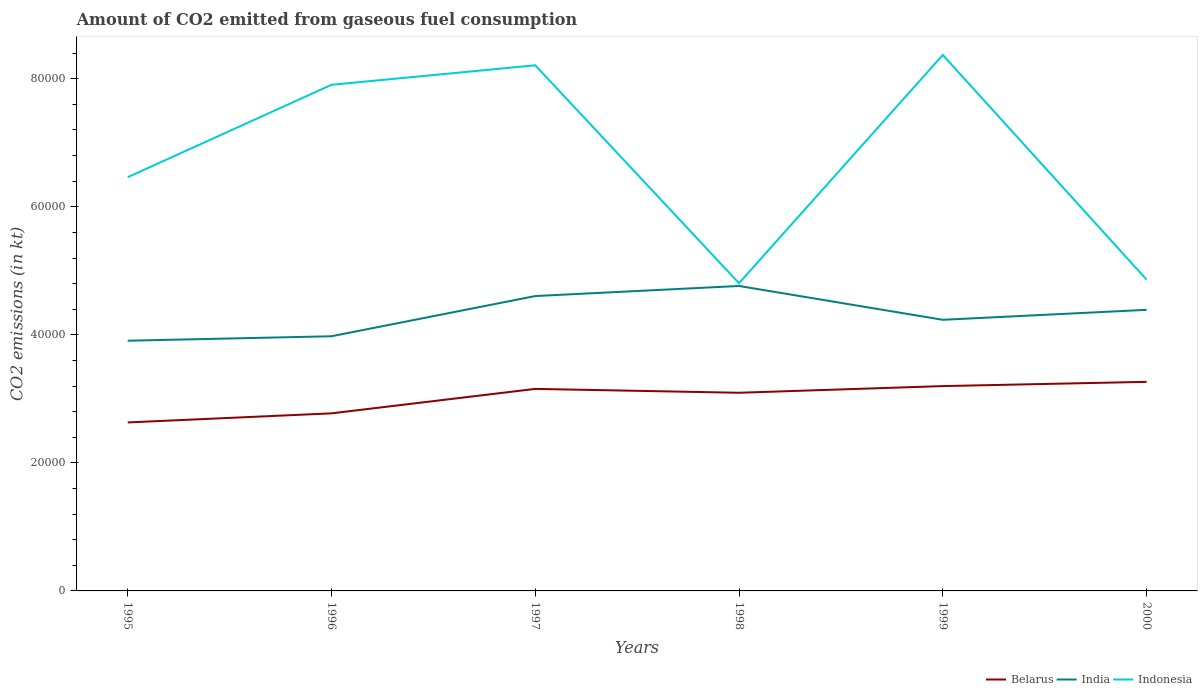Does the line corresponding to Indonesia intersect with the line corresponding to Belarus?
Make the answer very short. No. Across all years, what is the maximum amount of CO2 emitted in Indonesia?
Offer a terse response. 4.81e+04. What is the total amount of CO2 emitted in Indonesia in the graph?
Your answer should be compact. 3.51e+04. What is the difference between the highest and the second highest amount of CO2 emitted in Indonesia?
Your answer should be compact. 3.57e+04. What is the difference between the highest and the lowest amount of CO2 emitted in Indonesia?
Make the answer very short. 3. Is the amount of CO2 emitted in Belarus strictly greater than the amount of CO2 emitted in Indonesia over the years?
Provide a short and direct response. Yes. What is the difference between two consecutive major ticks on the Y-axis?
Ensure brevity in your answer.  2.00e+04. Does the graph contain grids?
Make the answer very short. No. How many legend labels are there?
Offer a very short reply. 3. What is the title of the graph?
Make the answer very short. Amount of CO2 emitted from gaseous fuel consumption. Does "Egypt, Arab Rep." appear as one of the legend labels in the graph?
Provide a short and direct response. No. What is the label or title of the Y-axis?
Keep it short and to the point. CO2 emissions (in kt). What is the CO2 emissions (in kt) in Belarus in 1995?
Offer a very short reply. 2.63e+04. What is the CO2 emissions (in kt) in India in 1995?
Offer a terse response. 3.91e+04. What is the CO2 emissions (in kt) in Indonesia in 1995?
Your answer should be very brief. 6.46e+04. What is the CO2 emissions (in kt) of Belarus in 1996?
Give a very brief answer. 2.77e+04. What is the CO2 emissions (in kt) in India in 1996?
Keep it short and to the point. 3.98e+04. What is the CO2 emissions (in kt) in Indonesia in 1996?
Provide a short and direct response. 7.91e+04. What is the CO2 emissions (in kt) of Belarus in 1997?
Offer a very short reply. 3.16e+04. What is the CO2 emissions (in kt) of India in 1997?
Offer a terse response. 4.61e+04. What is the CO2 emissions (in kt) of Indonesia in 1997?
Your answer should be compact. 8.21e+04. What is the CO2 emissions (in kt) of Belarus in 1998?
Your answer should be very brief. 3.10e+04. What is the CO2 emissions (in kt) in India in 1998?
Your answer should be compact. 4.76e+04. What is the CO2 emissions (in kt) in Indonesia in 1998?
Your answer should be compact. 4.81e+04. What is the CO2 emissions (in kt) in Belarus in 1999?
Ensure brevity in your answer.  3.20e+04. What is the CO2 emissions (in kt) in India in 1999?
Give a very brief answer. 4.24e+04. What is the CO2 emissions (in kt) of Indonesia in 1999?
Ensure brevity in your answer.  8.37e+04. What is the CO2 emissions (in kt) in Belarus in 2000?
Give a very brief answer. 3.27e+04. What is the CO2 emissions (in kt) of India in 2000?
Ensure brevity in your answer.  4.39e+04. What is the CO2 emissions (in kt) of Indonesia in 2000?
Provide a short and direct response. 4.86e+04. Across all years, what is the maximum CO2 emissions (in kt) of Belarus?
Your response must be concise. 3.27e+04. Across all years, what is the maximum CO2 emissions (in kt) of India?
Make the answer very short. 4.76e+04. Across all years, what is the maximum CO2 emissions (in kt) of Indonesia?
Provide a succinct answer. 8.37e+04. Across all years, what is the minimum CO2 emissions (in kt) in Belarus?
Keep it short and to the point. 2.63e+04. Across all years, what is the minimum CO2 emissions (in kt) of India?
Your answer should be very brief. 3.91e+04. Across all years, what is the minimum CO2 emissions (in kt) in Indonesia?
Your answer should be compact. 4.81e+04. What is the total CO2 emissions (in kt) in Belarus in the graph?
Give a very brief answer. 1.81e+05. What is the total CO2 emissions (in kt) in India in the graph?
Ensure brevity in your answer.  2.59e+05. What is the total CO2 emissions (in kt) in Indonesia in the graph?
Offer a terse response. 4.06e+05. What is the difference between the CO2 emissions (in kt) of Belarus in 1995 and that in 1996?
Ensure brevity in your answer.  -1419.13. What is the difference between the CO2 emissions (in kt) of India in 1995 and that in 1996?
Give a very brief answer. -696.73. What is the difference between the CO2 emissions (in kt) in Indonesia in 1995 and that in 1996?
Offer a very short reply. -1.44e+04. What is the difference between the CO2 emissions (in kt) of Belarus in 1995 and that in 1997?
Your answer should be compact. -5240.14. What is the difference between the CO2 emissions (in kt) of India in 1995 and that in 1997?
Provide a succinct answer. -6978.3. What is the difference between the CO2 emissions (in kt) in Indonesia in 1995 and that in 1997?
Your response must be concise. -1.75e+04. What is the difference between the CO2 emissions (in kt) in Belarus in 1995 and that in 1998?
Provide a succinct answer. -4635.09. What is the difference between the CO2 emissions (in kt) in India in 1995 and that in 1998?
Provide a short and direct response. -8551.44. What is the difference between the CO2 emissions (in kt) in Indonesia in 1995 and that in 1998?
Offer a terse response. 1.66e+04. What is the difference between the CO2 emissions (in kt) in Belarus in 1995 and that in 1999?
Make the answer very short. -5676.52. What is the difference between the CO2 emissions (in kt) in India in 1995 and that in 1999?
Offer a very short reply. -3267.3. What is the difference between the CO2 emissions (in kt) in Indonesia in 1995 and that in 1999?
Provide a short and direct response. -1.91e+04. What is the difference between the CO2 emissions (in kt) in Belarus in 1995 and that in 2000?
Offer a very short reply. -6340.24. What is the difference between the CO2 emissions (in kt) in India in 1995 and that in 2000?
Your response must be concise. -4825.77. What is the difference between the CO2 emissions (in kt) of Indonesia in 1995 and that in 2000?
Keep it short and to the point. 1.60e+04. What is the difference between the CO2 emissions (in kt) in Belarus in 1996 and that in 1997?
Make the answer very short. -3821.01. What is the difference between the CO2 emissions (in kt) of India in 1996 and that in 1997?
Your response must be concise. -6281.57. What is the difference between the CO2 emissions (in kt) of Indonesia in 1996 and that in 1997?
Give a very brief answer. -3050.94. What is the difference between the CO2 emissions (in kt) of Belarus in 1996 and that in 1998?
Give a very brief answer. -3215.96. What is the difference between the CO2 emissions (in kt) in India in 1996 and that in 1998?
Keep it short and to the point. -7854.71. What is the difference between the CO2 emissions (in kt) in Indonesia in 1996 and that in 1998?
Offer a terse response. 3.10e+04. What is the difference between the CO2 emissions (in kt) of Belarus in 1996 and that in 1999?
Offer a terse response. -4257.39. What is the difference between the CO2 emissions (in kt) of India in 1996 and that in 1999?
Your response must be concise. -2570.57. What is the difference between the CO2 emissions (in kt) in Indonesia in 1996 and that in 1999?
Make the answer very short. -4664.42. What is the difference between the CO2 emissions (in kt) in Belarus in 1996 and that in 2000?
Offer a very short reply. -4921.11. What is the difference between the CO2 emissions (in kt) in India in 1996 and that in 2000?
Provide a short and direct response. -4129.04. What is the difference between the CO2 emissions (in kt) in Indonesia in 1996 and that in 2000?
Offer a terse response. 3.04e+04. What is the difference between the CO2 emissions (in kt) in Belarus in 1997 and that in 1998?
Your answer should be very brief. 605.05. What is the difference between the CO2 emissions (in kt) in India in 1997 and that in 1998?
Ensure brevity in your answer.  -1573.14. What is the difference between the CO2 emissions (in kt) of Indonesia in 1997 and that in 1998?
Offer a very short reply. 3.40e+04. What is the difference between the CO2 emissions (in kt) in Belarus in 1997 and that in 1999?
Ensure brevity in your answer.  -436.37. What is the difference between the CO2 emissions (in kt) of India in 1997 and that in 1999?
Offer a very short reply. 3711. What is the difference between the CO2 emissions (in kt) of Indonesia in 1997 and that in 1999?
Ensure brevity in your answer.  -1613.48. What is the difference between the CO2 emissions (in kt) in Belarus in 1997 and that in 2000?
Ensure brevity in your answer.  -1100.1. What is the difference between the CO2 emissions (in kt) of India in 1997 and that in 2000?
Your answer should be very brief. 2152.53. What is the difference between the CO2 emissions (in kt) of Indonesia in 1997 and that in 2000?
Give a very brief answer. 3.35e+04. What is the difference between the CO2 emissions (in kt) in Belarus in 1998 and that in 1999?
Keep it short and to the point. -1041.43. What is the difference between the CO2 emissions (in kt) in India in 1998 and that in 1999?
Offer a terse response. 5284.15. What is the difference between the CO2 emissions (in kt) in Indonesia in 1998 and that in 1999?
Ensure brevity in your answer.  -3.57e+04. What is the difference between the CO2 emissions (in kt) in Belarus in 1998 and that in 2000?
Your answer should be compact. -1705.15. What is the difference between the CO2 emissions (in kt) in India in 1998 and that in 2000?
Ensure brevity in your answer.  3725.67. What is the difference between the CO2 emissions (in kt) in Indonesia in 1998 and that in 2000?
Ensure brevity in your answer.  -564.72. What is the difference between the CO2 emissions (in kt) in Belarus in 1999 and that in 2000?
Ensure brevity in your answer.  -663.73. What is the difference between the CO2 emissions (in kt) of India in 1999 and that in 2000?
Ensure brevity in your answer.  -1558.47. What is the difference between the CO2 emissions (in kt) of Indonesia in 1999 and that in 2000?
Offer a very short reply. 3.51e+04. What is the difference between the CO2 emissions (in kt) in Belarus in 1995 and the CO2 emissions (in kt) in India in 1996?
Provide a succinct answer. -1.35e+04. What is the difference between the CO2 emissions (in kt) in Belarus in 1995 and the CO2 emissions (in kt) in Indonesia in 1996?
Provide a succinct answer. -5.27e+04. What is the difference between the CO2 emissions (in kt) of India in 1995 and the CO2 emissions (in kt) of Indonesia in 1996?
Offer a terse response. -4.00e+04. What is the difference between the CO2 emissions (in kt) of Belarus in 1995 and the CO2 emissions (in kt) of India in 1997?
Your response must be concise. -1.97e+04. What is the difference between the CO2 emissions (in kt) of Belarus in 1995 and the CO2 emissions (in kt) of Indonesia in 1997?
Your answer should be very brief. -5.58e+04. What is the difference between the CO2 emissions (in kt) of India in 1995 and the CO2 emissions (in kt) of Indonesia in 1997?
Provide a succinct answer. -4.30e+04. What is the difference between the CO2 emissions (in kt) in Belarus in 1995 and the CO2 emissions (in kt) in India in 1998?
Keep it short and to the point. -2.13e+04. What is the difference between the CO2 emissions (in kt) in Belarus in 1995 and the CO2 emissions (in kt) in Indonesia in 1998?
Make the answer very short. -2.17e+04. What is the difference between the CO2 emissions (in kt) in India in 1995 and the CO2 emissions (in kt) in Indonesia in 1998?
Your answer should be compact. -8984.15. What is the difference between the CO2 emissions (in kt) of Belarus in 1995 and the CO2 emissions (in kt) of India in 1999?
Give a very brief answer. -1.60e+04. What is the difference between the CO2 emissions (in kt) of Belarus in 1995 and the CO2 emissions (in kt) of Indonesia in 1999?
Ensure brevity in your answer.  -5.74e+04. What is the difference between the CO2 emissions (in kt) in India in 1995 and the CO2 emissions (in kt) in Indonesia in 1999?
Make the answer very short. -4.46e+04. What is the difference between the CO2 emissions (in kt) in Belarus in 1995 and the CO2 emissions (in kt) in India in 2000?
Provide a succinct answer. -1.76e+04. What is the difference between the CO2 emissions (in kt) in Belarus in 1995 and the CO2 emissions (in kt) in Indonesia in 2000?
Your answer should be very brief. -2.23e+04. What is the difference between the CO2 emissions (in kt) of India in 1995 and the CO2 emissions (in kt) of Indonesia in 2000?
Your answer should be compact. -9548.87. What is the difference between the CO2 emissions (in kt) of Belarus in 1996 and the CO2 emissions (in kt) of India in 1997?
Offer a terse response. -1.83e+04. What is the difference between the CO2 emissions (in kt) in Belarus in 1996 and the CO2 emissions (in kt) in Indonesia in 1997?
Give a very brief answer. -5.44e+04. What is the difference between the CO2 emissions (in kt) of India in 1996 and the CO2 emissions (in kt) of Indonesia in 1997?
Provide a succinct answer. -4.23e+04. What is the difference between the CO2 emissions (in kt) of Belarus in 1996 and the CO2 emissions (in kt) of India in 1998?
Your answer should be compact. -1.99e+04. What is the difference between the CO2 emissions (in kt) of Belarus in 1996 and the CO2 emissions (in kt) of Indonesia in 1998?
Make the answer very short. -2.03e+04. What is the difference between the CO2 emissions (in kt) of India in 1996 and the CO2 emissions (in kt) of Indonesia in 1998?
Offer a very short reply. -8287.42. What is the difference between the CO2 emissions (in kt) in Belarus in 1996 and the CO2 emissions (in kt) in India in 1999?
Keep it short and to the point. -1.46e+04. What is the difference between the CO2 emissions (in kt) of Belarus in 1996 and the CO2 emissions (in kt) of Indonesia in 1999?
Your response must be concise. -5.60e+04. What is the difference between the CO2 emissions (in kt) in India in 1996 and the CO2 emissions (in kt) in Indonesia in 1999?
Ensure brevity in your answer.  -4.39e+04. What is the difference between the CO2 emissions (in kt) in Belarus in 1996 and the CO2 emissions (in kt) in India in 2000?
Offer a very short reply. -1.62e+04. What is the difference between the CO2 emissions (in kt) of Belarus in 1996 and the CO2 emissions (in kt) of Indonesia in 2000?
Provide a short and direct response. -2.09e+04. What is the difference between the CO2 emissions (in kt) in India in 1996 and the CO2 emissions (in kt) in Indonesia in 2000?
Offer a terse response. -8852.14. What is the difference between the CO2 emissions (in kt) in Belarus in 1997 and the CO2 emissions (in kt) in India in 1998?
Provide a short and direct response. -1.61e+04. What is the difference between the CO2 emissions (in kt) in Belarus in 1997 and the CO2 emissions (in kt) in Indonesia in 1998?
Your response must be concise. -1.65e+04. What is the difference between the CO2 emissions (in kt) in India in 1997 and the CO2 emissions (in kt) in Indonesia in 1998?
Keep it short and to the point. -2005.85. What is the difference between the CO2 emissions (in kt) in Belarus in 1997 and the CO2 emissions (in kt) in India in 1999?
Your response must be concise. -1.08e+04. What is the difference between the CO2 emissions (in kt) of Belarus in 1997 and the CO2 emissions (in kt) of Indonesia in 1999?
Ensure brevity in your answer.  -5.22e+04. What is the difference between the CO2 emissions (in kt) of India in 1997 and the CO2 emissions (in kt) of Indonesia in 1999?
Your response must be concise. -3.77e+04. What is the difference between the CO2 emissions (in kt) in Belarus in 1997 and the CO2 emissions (in kt) in India in 2000?
Offer a terse response. -1.24e+04. What is the difference between the CO2 emissions (in kt) in Belarus in 1997 and the CO2 emissions (in kt) in Indonesia in 2000?
Give a very brief answer. -1.71e+04. What is the difference between the CO2 emissions (in kt) of India in 1997 and the CO2 emissions (in kt) of Indonesia in 2000?
Provide a short and direct response. -2570.57. What is the difference between the CO2 emissions (in kt) of Belarus in 1998 and the CO2 emissions (in kt) of India in 1999?
Your response must be concise. -1.14e+04. What is the difference between the CO2 emissions (in kt) of Belarus in 1998 and the CO2 emissions (in kt) of Indonesia in 1999?
Keep it short and to the point. -5.28e+04. What is the difference between the CO2 emissions (in kt) in India in 1998 and the CO2 emissions (in kt) in Indonesia in 1999?
Offer a terse response. -3.61e+04. What is the difference between the CO2 emissions (in kt) in Belarus in 1998 and the CO2 emissions (in kt) in India in 2000?
Offer a terse response. -1.30e+04. What is the difference between the CO2 emissions (in kt) in Belarus in 1998 and the CO2 emissions (in kt) in Indonesia in 2000?
Provide a short and direct response. -1.77e+04. What is the difference between the CO2 emissions (in kt) of India in 1998 and the CO2 emissions (in kt) of Indonesia in 2000?
Provide a short and direct response. -997.42. What is the difference between the CO2 emissions (in kt) of Belarus in 1999 and the CO2 emissions (in kt) of India in 2000?
Offer a terse response. -1.19e+04. What is the difference between the CO2 emissions (in kt) in Belarus in 1999 and the CO2 emissions (in kt) in Indonesia in 2000?
Ensure brevity in your answer.  -1.66e+04. What is the difference between the CO2 emissions (in kt) in India in 1999 and the CO2 emissions (in kt) in Indonesia in 2000?
Offer a very short reply. -6281.57. What is the average CO2 emissions (in kt) in Belarus per year?
Your answer should be very brief. 3.02e+04. What is the average CO2 emissions (in kt) of India per year?
Ensure brevity in your answer.  4.31e+04. What is the average CO2 emissions (in kt) in Indonesia per year?
Your response must be concise. 6.77e+04. In the year 1995, what is the difference between the CO2 emissions (in kt) in Belarus and CO2 emissions (in kt) in India?
Offer a very short reply. -1.28e+04. In the year 1995, what is the difference between the CO2 emissions (in kt) in Belarus and CO2 emissions (in kt) in Indonesia?
Keep it short and to the point. -3.83e+04. In the year 1995, what is the difference between the CO2 emissions (in kt) in India and CO2 emissions (in kt) in Indonesia?
Keep it short and to the point. -2.55e+04. In the year 1996, what is the difference between the CO2 emissions (in kt) in Belarus and CO2 emissions (in kt) in India?
Offer a terse response. -1.20e+04. In the year 1996, what is the difference between the CO2 emissions (in kt) in Belarus and CO2 emissions (in kt) in Indonesia?
Ensure brevity in your answer.  -5.13e+04. In the year 1996, what is the difference between the CO2 emissions (in kt) of India and CO2 emissions (in kt) of Indonesia?
Ensure brevity in your answer.  -3.93e+04. In the year 1997, what is the difference between the CO2 emissions (in kt) in Belarus and CO2 emissions (in kt) in India?
Offer a very short reply. -1.45e+04. In the year 1997, what is the difference between the CO2 emissions (in kt) of Belarus and CO2 emissions (in kt) of Indonesia?
Provide a succinct answer. -5.05e+04. In the year 1997, what is the difference between the CO2 emissions (in kt) of India and CO2 emissions (in kt) of Indonesia?
Offer a very short reply. -3.60e+04. In the year 1998, what is the difference between the CO2 emissions (in kt) in Belarus and CO2 emissions (in kt) in India?
Offer a terse response. -1.67e+04. In the year 1998, what is the difference between the CO2 emissions (in kt) in Belarus and CO2 emissions (in kt) in Indonesia?
Provide a short and direct response. -1.71e+04. In the year 1998, what is the difference between the CO2 emissions (in kt) of India and CO2 emissions (in kt) of Indonesia?
Give a very brief answer. -432.71. In the year 1999, what is the difference between the CO2 emissions (in kt) in Belarus and CO2 emissions (in kt) in India?
Your answer should be very brief. -1.04e+04. In the year 1999, what is the difference between the CO2 emissions (in kt) in Belarus and CO2 emissions (in kt) in Indonesia?
Your answer should be compact. -5.17e+04. In the year 1999, what is the difference between the CO2 emissions (in kt) of India and CO2 emissions (in kt) of Indonesia?
Offer a very short reply. -4.14e+04. In the year 2000, what is the difference between the CO2 emissions (in kt) of Belarus and CO2 emissions (in kt) of India?
Your response must be concise. -1.13e+04. In the year 2000, what is the difference between the CO2 emissions (in kt) of Belarus and CO2 emissions (in kt) of Indonesia?
Offer a terse response. -1.60e+04. In the year 2000, what is the difference between the CO2 emissions (in kt) of India and CO2 emissions (in kt) of Indonesia?
Your response must be concise. -4723.1. What is the ratio of the CO2 emissions (in kt) in Belarus in 1995 to that in 1996?
Ensure brevity in your answer.  0.95. What is the ratio of the CO2 emissions (in kt) of India in 1995 to that in 1996?
Provide a succinct answer. 0.98. What is the ratio of the CO2 emissions (in kt) in Indonesia in 1995 to that in 1996?
Provide a short and direct response. 0.82. What is the ratio of the CO2 emissions (in kt) in Belarus in 1995 to that in 1997?
Ensure brevity in your answer.  0.83. What is the ratio of the CO2 emissions (in kt) in India in 1995 to that in 1997?
Give a very brief answer. 0.85. What is the ratio of the CO2 emissions (in kt) of Indonesia in 1995 to that in 1997?
Your answer should be compact. 0.79. What is the ratio of the CO2 emissions (in kt) in Belarus in 1995 to that in 1998?
Provide a short and direct response. 0.85. What is the ratio of the CO2 emissions (in kt) in India in 1995 to that in 1998?
Offer a very short reply. 0.82. What is the ratio of the CO2 emissions (in kt) of Indonesia in 1995 to that in 1998?
Offer a very short reply. 1.34. What is the ratio of the CO2 emissions (in kt) of Belarus in 1995 to that in 1999?
Your answer should be compact. 0.82. What is the ratio of the CO2 emissions (in kt) in India in 1995 to that in 1999?
Give a very brief answer. 0.92. What is the ratio of the CO2 emissions (in kt) of Indonesia in 1995 to that in 1999?
Provide a succinct answer. 0.77. What is the ratio of the CO2 emissions (in kt) in Belarus in 1995 to that in 2000?
Provide a succinct answer. 0.81. What is the ratio of the CO2 emissions (in kt) in India in 1995 to that in 2000?
Offer a terse response. 0.89. What is the ratio of the CO2 emissions (in kt) in Indonesia in 1995 to that in 2000?
Provide a succinct answer. 1.33. What is the ratio of the CO2 emissions (in kt) of Belarus in 1996 to that in 1997?
Keep it short and to the point. 0.88. What is the ratio of the CO2 emissions (in kt) in India in 1996 to that in 1997?
Your answer should be compact. 0.86. What is the ratio of the CO2 emissions (in kt) of Indonesia in 1996 to that in 1997?
Ensure brevity in your answer.  0.96. What is the ratio of the CO2 emissions (in kt) in Belarus in 1996 to that in 1998?
Your answer should be very brief. 0.9. What is the ratio of the CO2 emissions (in kt) of India in 1996 to that in 1998?
Make the answer very short. 0.84. What is the ratio of the CO2 emissions (in kt) of Indonesia in 1996 to that in 1998?
Keep it short and to the point. 1.64. What is the ratio of the CO2 emissions (in kt) of Belarus in 1996 to that in 1999?
Offer a terse response. 0.87. What is the ratio of the CO2 emissions (in kt) of India in 1996 to that in 1999?
Make the answer very short. 0.94. What is the ratio of the CO2 emissions (in kt) in Indonesia in 1996 to that in 1999?
Ensure brevity in your answer.  0.94. What is the ratio of the CO2 emissions (in kt) of Belarus in 1996 to that in 2000?
Your answer should be very brief. 0.85. What is the ratio of the CO2 emissions (in kt) of India in 1996 to that in 2000?
Ensure brevity in your answer.  0.91. What is the ratio of the CO2 emissions (in kt) in Indonesia in 1996 to that in 2000?
Keep it short and to the point. 1.63. What is the ratio of the CO2 emissions (in kt) in Belarus in 1997 to that in 1998?
Ensure brevity in your answer.  1.02. What is the ratio of the CO2 emissions (in kt) of Indonesia in 1997 to that in 1998?
Keep it short and to the point. 1.71. What is the ratio of the CO2 emissions (in kt) in Belarus in 1997 to that in 1999?
Offer a terse response. 0.99. What is the ratio of the CO2 emissions (in kt) in India in 1997 to that in 1999?
Give a very brief answer. 1.09. What is the ratio of the CO2 emissions (in kt) of Indonesia in 1997 to that in 1999?
Give a very brief answer. 0.98. What is the ratio of the CO2 emissions (in kt) of Belarus in 1997 to that in 2000?
Provide a succinct answer. 0.97. What is the ratio of the CO2 emissions (in kt) of India in 1997 to that in 2000?
Keep it short and to the point. 1.05. What is the ratio of the CO2 emissions (in kt) of Indonesia in 1997 to that in 2000?
Provide a succinct answer. 1.69. What is the ratio of the CO2 emissions (in kt) in Belarus in 1998 to that in 1999?
Your answer should be compact. 0.97. What is the ratio of the CO2 emissions (in kt) in India in 1998 to that in 1999?
Offer a terse response. 1.12. What is the ratio of the CO2 emissions (in kt) in Indonesia in 1998 to that in 1999?
Offer a very short reply. 0.57. What is the ratio of the CO2 emissions (in kt) in Belarus in 1998 to that in 2000?
Ensure brevity in your answer.  0.95. What is the ratio of the CO2 emissions (in kt) of India in 1998 to that in 2000?
Offer a very short reply. 1.08. What is the ratio of the CO2 emissions (in kt) of Indonesia in 1998 to that in 2000?
Provide a short and direct response. 0.99. What is the ratio of the CO2 emissions (in kt) in Belarus in 1999 to that in 2000?
Offer a very short reply. 0.98. What is the ratio of the CO2 emissions (in kt) in India in 1999 to that in 2000?
Offer a terse response. 0.96. What is the ratio of the CO2 emissions (in kt) in Indonesia in 1999 to that in 2000?
Your response must be concise. 1.72. What is the difference between the highest and the second highest CO2 emissions (in kt) of Belarus?
Offer a terse response. 663.73. What is the difference between the highest and the second highest CO2 emissions (in kt) in India?
Provide a succinct answer. 1573.14. What is the difference between the highest and the second highest CO2 emissions (in kt) in Indonesia?
Offer a very short reply. 1613.48. What is the difference between the highest and the lowest CO2 emissions (in kt) in Belarus?
Offer a terse response. 6340.24. What is the difference between the highest and the lowest CO2 emissions (in kt) of India?
Keep it short and to the point. 8551.44. What is the difference between the highest and the lowest CO2 emissions (in kt) of Indonesia?
Provide a short and direct response. 3.57e+04. 